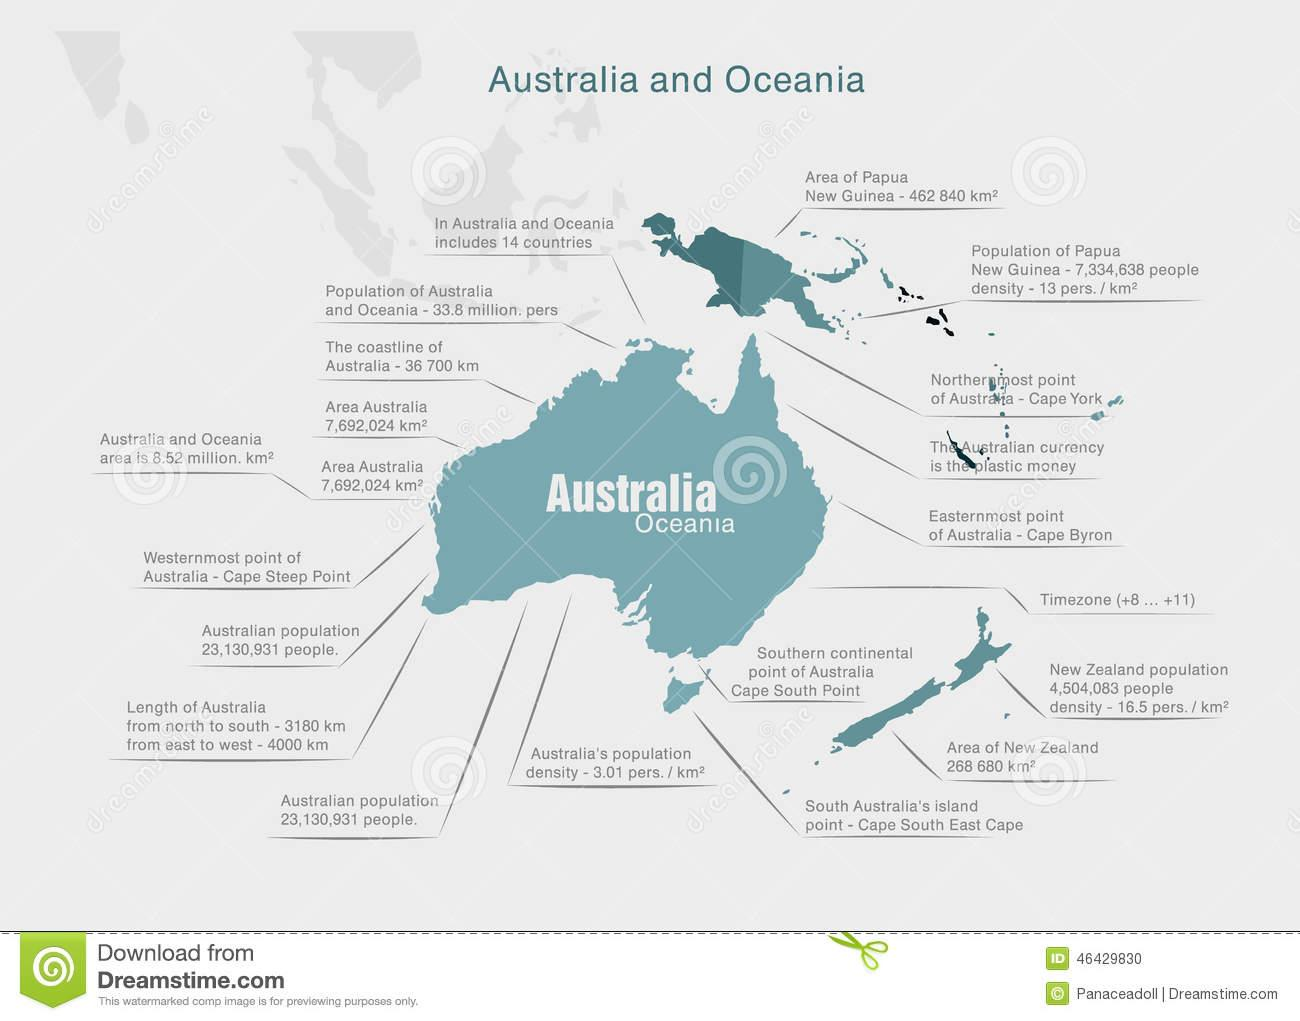Specify some key components in this picture. Australia's currency is unique in that it consists of plastic money. 